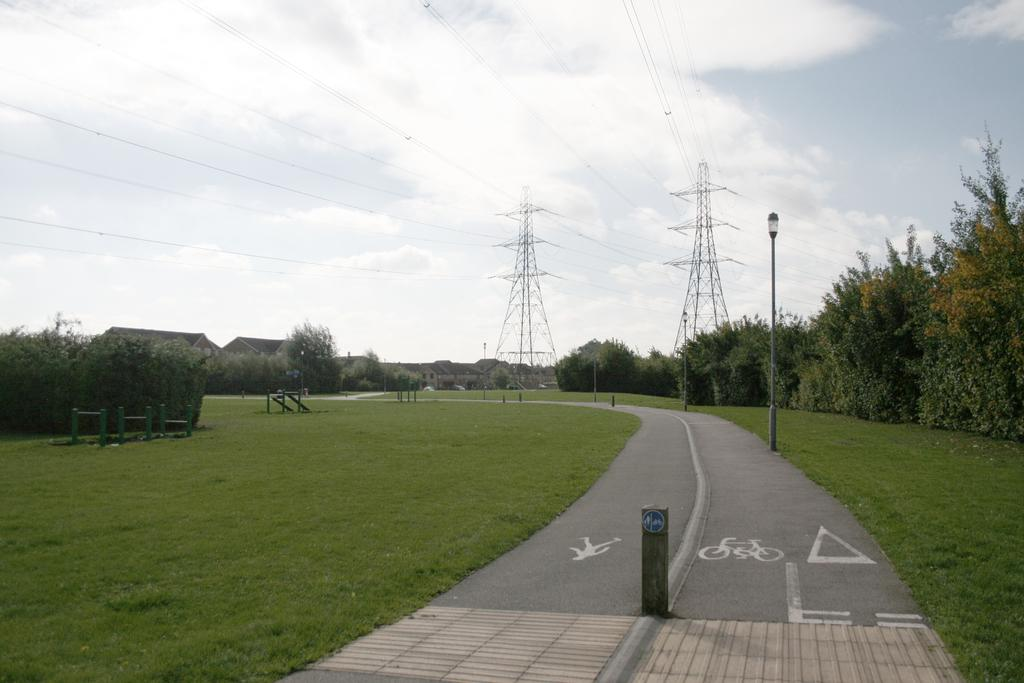What is the main feature of the image? There is a road in the image. What can be seen in the background of the image? There are trees in the background of the image, and they are green. What structures are present in the image? There are light poles, towers, and houses in the image. What is visible in the sky in the image? The sky is visible in the image, and it has a white and gray color. Is there a garden visible in the image? There is no garden present in the image. What time of day is it in the image? The time of day cannot be determined from the image, as there are no specific indicators of time. 